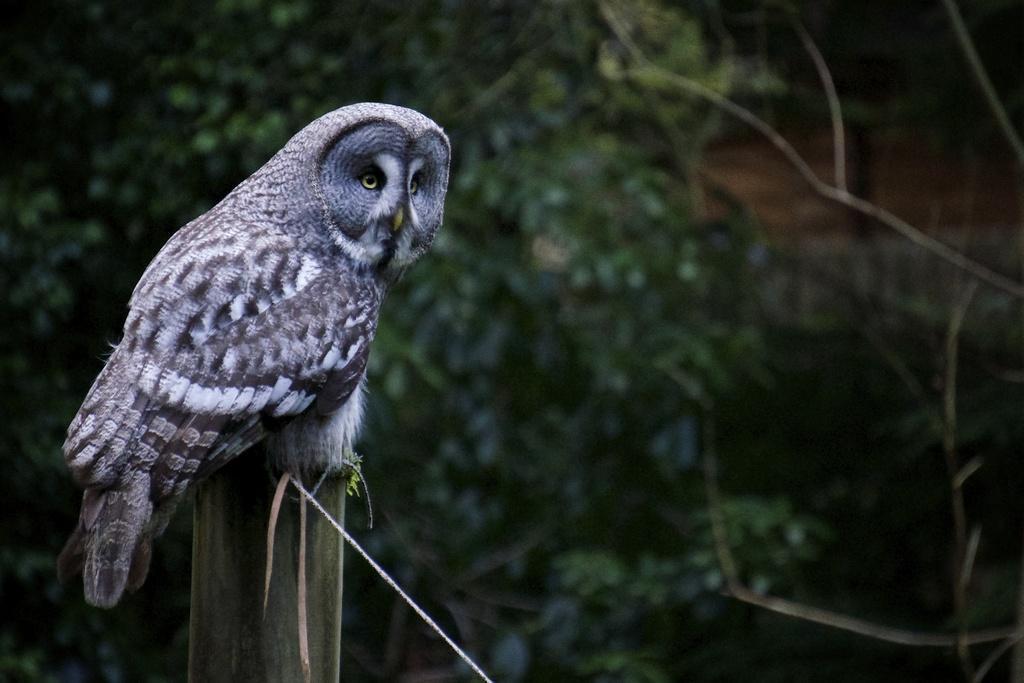Describe this image in one or two sentences. In the picture I can see an owl on the wooden pole. In the background, I can see the trees. 